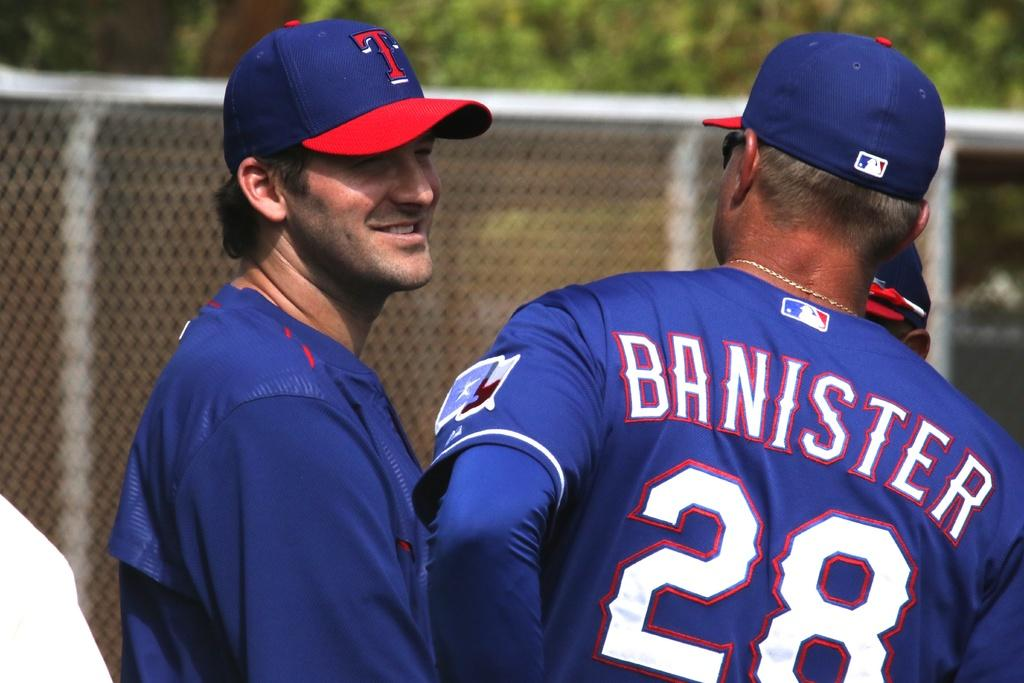Provide a one-sentence caption for the provided image. a man with a blue shirt with the name Banister on it. 